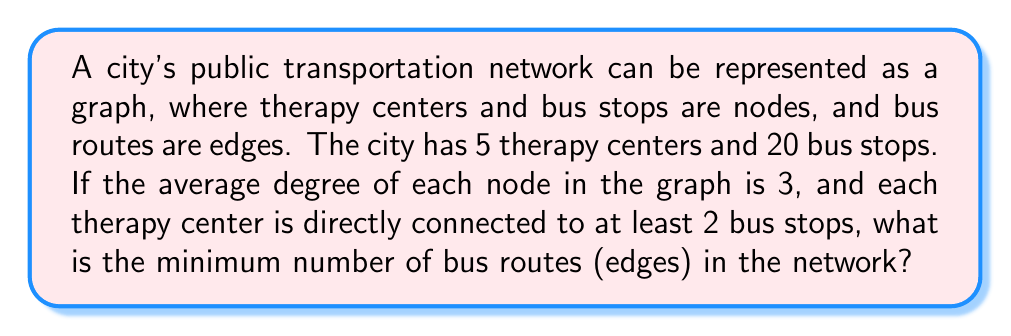Could you help me with this problem? Let's approach this step-by-step:

1) First, we need to calculate the total number of nodes in the graph:
   - Number of therapy centers = 5
   - Number of bus stops = 20
   - Total nodes = 5 + 20 = 25

2) In graph theory, the handshaking lemma states that the sum of degrees of all vertices is equal to twice the number of edges. Let's call the number of edges $e$. So:

   $$ \sum_{v \in V} \deg(v) = 2e $$

3) We're given that the average degree is 3. For a graph with $n$ vertices:

   $$ \frac{\sum_{v \in V} \deg(v)}{n} = 3 $$

4) Combining these:

   $$ \frac{2e}{25} = 3 $$

5) Solving for $e$:

   $$ e = \frac{3 \times 25}{2} = 37.5 $$

6) However, we need the minimum number of edges, so we round up to 38.

7) Now, we need to check if this satisfies the condition that each therapy center is connected to at least 2 bus stops. The minimum number of edges for this condition is:

   $$ 5 \times 2 = 10 $$

8) Since 38 > 10, our calculated number of edges satisfies this condition.

Therefore, the minimum number of bus routes (edges) in the network is 38.
Answer: 38 bus routes 